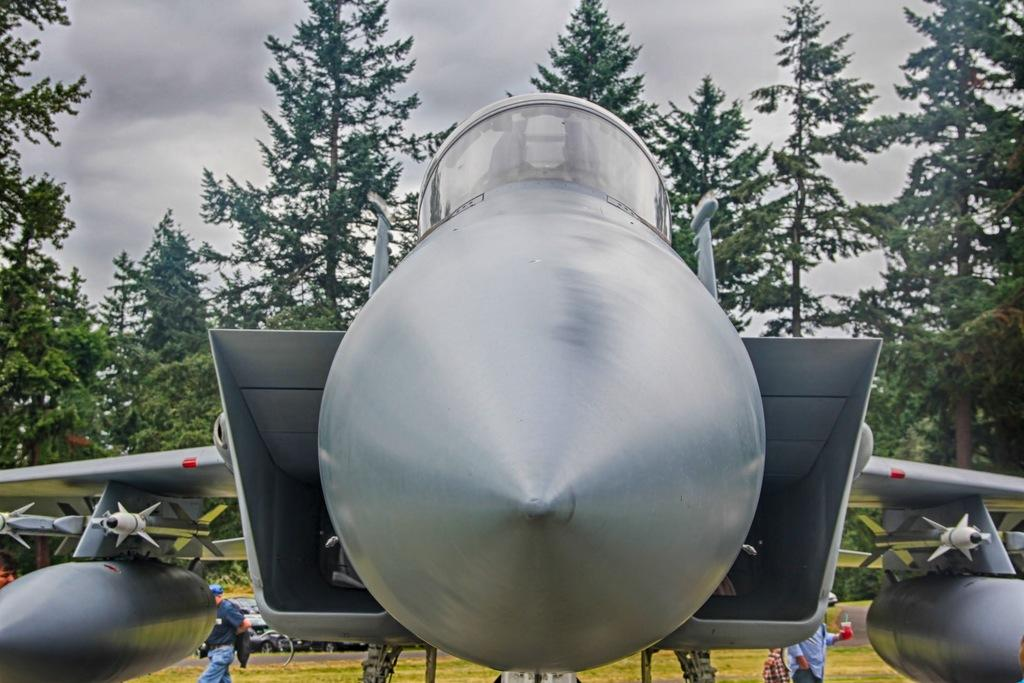What is the main subject of the picture? The main subject of the picture is an airplane. What other types of transportation can be seen in the picture? There are vehicles in the picture. What natural elements are present in the picture? There are trees in the picture. What are the people in the picture doing? The people are on the grass in the picture. What can be seen in the background of the picture? The sky with clouds is visible in the background of the picture. How many fifths are visible in the picture? There is no reference to a "fifth" in the image, so it cannot be determined how many are visible. --- Facts: 1. There is a person holding a book in the image. 2. The person is sitting on a chair. 3. There is a table in the image. 4. The table has a lamp on it. 5. There is a window in the room. Absurd Topics: elephant, ocean, dance Conversation: What is the person in the image holding? The person is holding a book in the image. What is the person sitting on? The person is sitting on a chair. What piece of furniture is present in the image besides the chair? There is a table in the image. What is on the table? The table has a lamp on it. What can be seen through the window in the room? There is no information about what can be seen through the window in the image. Reasoning: Let's think step by step in order to produce the conversation. We start by identifying the main subject in the image, which is the person holding a book. Then, we expand the conversation to include other subjects and objects in the image, such as the chair, table, and lamp. Each question is designed to elicit a specific detail about the image that is known from the provided facts. Absurd Question/Answer: Can you see an elephant swimming in the ocean in the image? There is no elephant or ocean present in the image. 